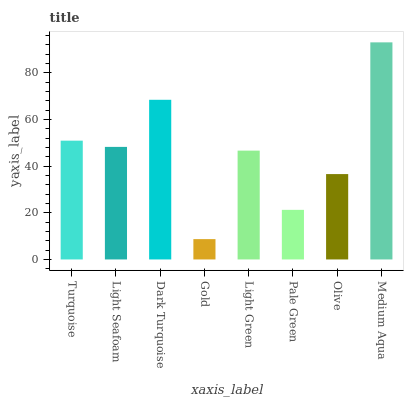Is Gold the minimum?
Answer yes or no. Yes. Is Medium Aqua the maximum?
Answer yes or no. Yes. Is Light Seafoam the minimum?
Answer yes or no. No. Is Light Seafoam the maximum?
Answer yes or no. No. Is Turquoise greater than Light Seafoam?
Answer yes or no. Yes. Is Light Seafoam less than Turquoise?
Answer yes or no. Yes. Is Light Seafoam greater than Turquoise?
Answer yes or no. No. Is Turquoise less than Light Seafoam?
Answer yes or no. No. Is Light Seafoam the high median?
Answer yes or no. Yes. Is Light Green the low median?
Answer yes or no. Yes. Is Dark Turquoise the high median?
Answer yes or no. No. Is Olive the low median?
Answer yes or no. No. 